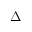<formula> <loc_0><loc_0><loc_500><loc_500>\Delta</formula> 